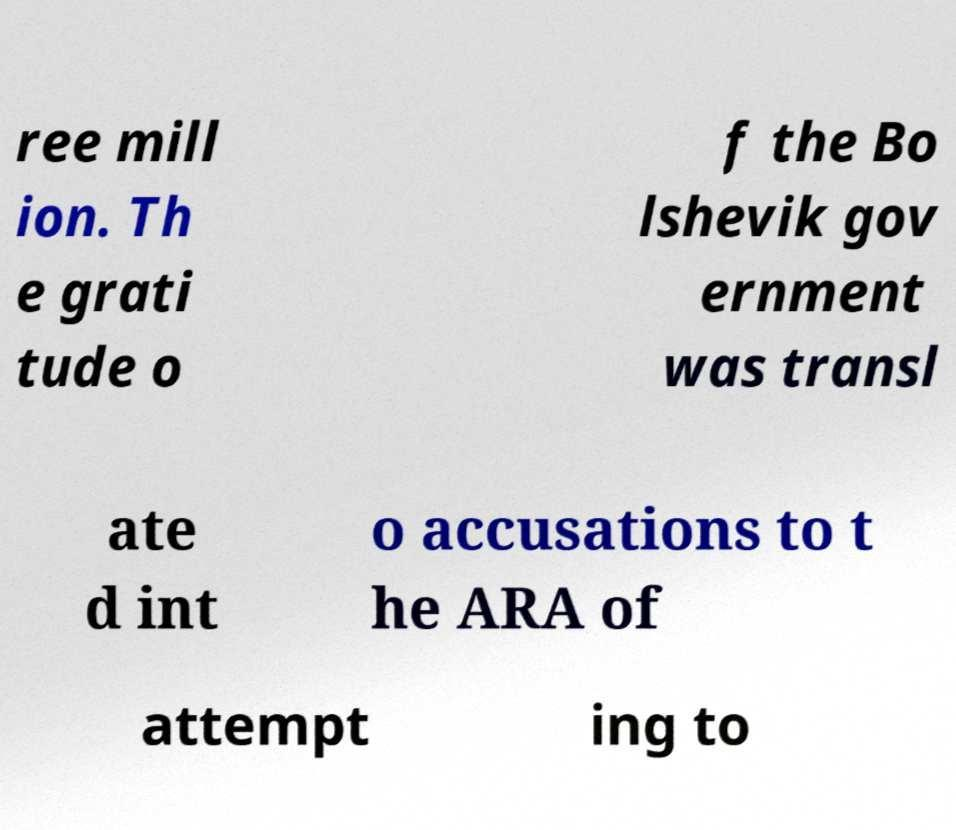Please read and relay the text visible in this image. What does it say? ree mill ion. Th e grati tude o f the Bo lshevik gov ernment was transl ate d int o accusations to t he ARA of attempt ing to 